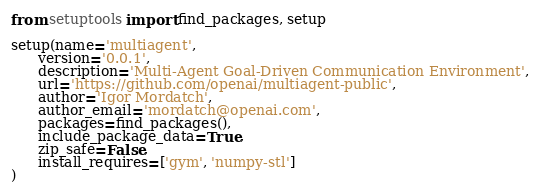Convert code to text. <code><loc_0><loc_0><loc_500><loc_500><_Python_>from setuptools import find_packages, setup

setup(name='multiagent',
      version='0.0.1',
      description='Multi-Agent Goal-Driven Communication Environment',
      url='https://github.com/openai/multiagent-public',
      author='Igor Mordatch',
      author_email='mordatch@openai.com',
      packages=find_packages(),
      include_package_data=True,
      zip_safe=False,
      install_requires=['gym', 'numpy-stl']
)
</code> 